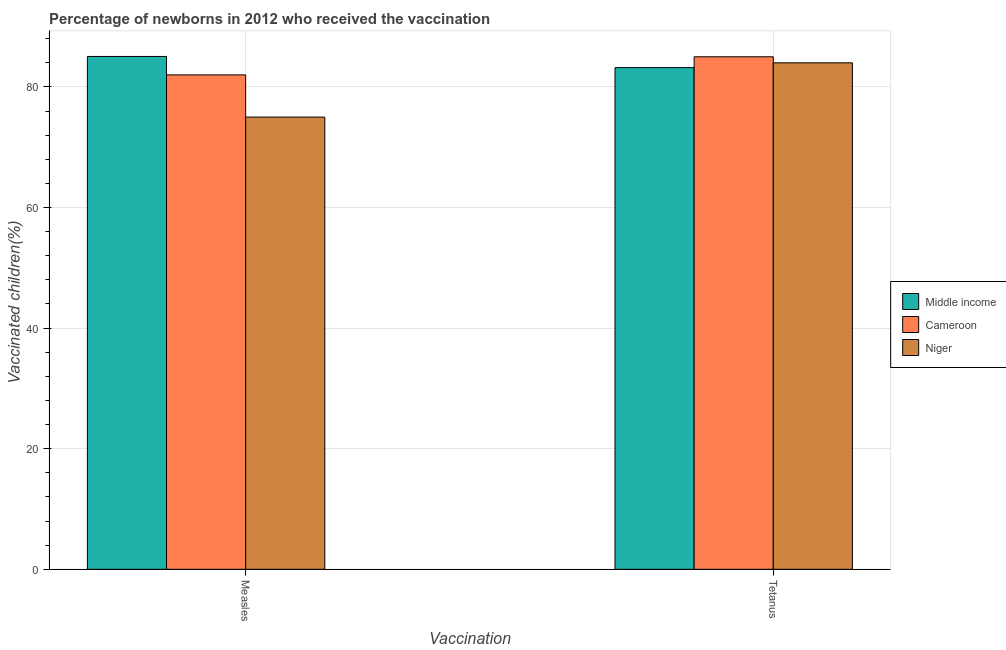How many different coloured bars are there?
Your answer should be compact. 3. How many groups of bars are there?
Your answer should be very brief. 2. How many bars are there on the 2nd tick from the right?
Keep it short and to the point. 3. What is the label of the 1st group of bars from the left?
Your answer should be compact. Measles. What is the percentage of newborns who received vaccination for measles in Middle income?
Offer a very short reply. 85.05. Across all countries, what is the minimum percentage of newborns who received vaccination for measles?
Your response must be concise. 75. In which country was the percentage of newborns who received vaccination for measles minimum?
Your answer should be compact. Niger. What is the total percentage of newborns who received vaccination for tetanus in the graph?
Provide a succinct answer. 252.2. What is the difference between the percentage of newborns who received vaccination for measles in Middle income and that in Cameroon?
Offer a very short reply. 3.05. What is the difference between the percentage of newborns who received vaccination for tetanus in Cameroon and the percentage of newborns who received vaccination for measles in Niger?
Offer a very short reply. 10. What is the average percentage of newborns who received vaccination for tetanus per country?
Your response must be concise. 84.07. What is the difference between the percentage of newborns who received vaccination for measles and percentage of newborns who received vaccination for tetanus in Middle income?
Make the answer very short. 1.85. What is the ratio of the percentage of newborns who received vaccination for measles in Middle income to that in Niger?
Your answer should be very brief. 1.13. In how many countries, is the percentage of newborns who received vaccination for tetanus greater than the average percentage of newborns who received vaccination for tetanus taken over all countries?
Provide a succinct answer. 1. What does the 2nd bar from the left in Measles represents?
Your answer should be very brief. Cameroon. What does the 2nd bar from the right in Measles represents?
Ensure brevity in your answer.  Cameroon. How many bars are there?
Offer a very short reply. 6. Are the values on the major ticks of Y-axis written in scientific E-notation?
Make the answer very short. No. Does the graph contain grids?
Make the answer very short. Yes. Where does the legend appear in the graph?
Ensure brevity in your answer.  Center right. How many legend labels are there?
Ensure brevity in your answer.  3. How are the legend labels stacked?
Provide a short and direct response. Vertical. What is the title of the graph?
Offer a terse response. Percentage of newborns in 2012 who received the vaccination. What is the label or title of the X-axis?
Your response must be concise. Vaccination. What is the label or title of the Y-axis?
Offer a terse response. Vaccinated children(%)
. What is the Vaccinated children(%)
 in Middle income in Measles?
Offer a terse response. 85.05. What is the Vaccinated children(%)
 of Cameroon in Measles?
Make the answer very short. 82. What is the Vaccinated children(%)
 of Middle income in Tetanus?
Offer a terse response. 83.2. What is the Vaccinated children(%)
 of Cameroon in Tetanus?
Ensure brevity in your answer.  85. Across all Vaccination, what is the maximum Vaccinated children(%)
 in Middle income?
Ensure brevity in your answer.  85.05. Across all Vaccination, what is the maximum Vaccinated children(%)
 of Cameroon?
Give a very brief answer. 85. Across all Vaccination, what is the minimum Vaccinated children(%)
 in Middle income?
Your answer should be very brief. 83.2. What is the total Vaccinated children(%)
 of Middle income in the graph?
Keep it short and to the point. 168.26. What is the total Vaccinated children(%)
 of Cameroon in the graph?
Provide a short and direct response. 167. What is the total Vaccinated children(%)
 in Niger in the graph?
Provide a succinct answer. 159. What is the difference between the Vaccinated children(%)
 in Middle income in Measles and that in Tetanus?
Make the answer very short. 1.85. What is the difference between the Vaccinated children(%)
 of Cameroon in Measles and that in Tetanus?
Your response must be concise. -3. What is the difference between the Vaccinated children(%)
 of Middle income in Measles and the Vaccinated children(%)
 of Cameroon in Tetanus?
Ensure brevity in your answer.  0.05. What is the difference between the Vaccinated children(%)
 of Middle income in Measles and the Vaccinated children(%)
 of Niger in Tetanus?
Your response must be concise. 1.05. What is the average Vaccinated children(%)
 in Middle income per Vaccination?
Provide a succinct answer. 84.13. What is the average Vaccinated children(%)
 of Cameroon per Vaccination?
Your answer should be compact. 83.5. What is the average Vaccinated children(%)
 of Niger per Vaccination?
Provide a succinct answer. 79.5. What is the difference between the Vaccinated children(%)
 in Middle income and Vaccinated children(%)
 in Cameroon in Measles?
Provide a succinct answer. 3.05. What is the difference between the Vaccinated children(%)
 of Middle income and Vaccinated children(%)
 of Niger in Measles?
Offer a very short reply. 10.05. What is the difference between the Vaccinated children(%)
 in Middle income and Vaccinated children(%)
 in Cameroon in Tetanus?
Make the answer very short. -1.8. What is the difference between the Vaccinated children(%)
 in Middle income and Vaccinated children(%)
 in Niger in Tetanus?
Your answer should be very brief. -0.8. What is the ratio of the Vaccinated children(%)
 of Middle income in Measles to that in Tetanus?
Provide a short and direct response. 1.02. What is the ratio of the Vaccinated children(%)
 of Cameroon in Measles to that in Tetanus?
Provide a succinct answer. 0.96. What is the ratio of the Vaccinated children(%)
 of Niger in Measles to that in Tetanus?
Provide a succinct answer. 0.89. What is the difference between the highest and the second highest Vaccinated children(%)
 in Middle income?
Make the answer very short. 1.85. What is the difference between the highest and the second highest Vaccinated children(%)
 in Niger?
Your response must be concise. 9. What is the difference between the highest and the lowest Vaccinated children(%)
 in Middle income?
Keep it short and to the point. 1.85. What is the difference between the highest and the lowest Vaccinated children(%)
 in Cameroon?
Make the answer very short. 3. What is the difference between the highest and the lowest Vaccinated children(%)
 in Niger?
Keep it short and to the point. 9. 